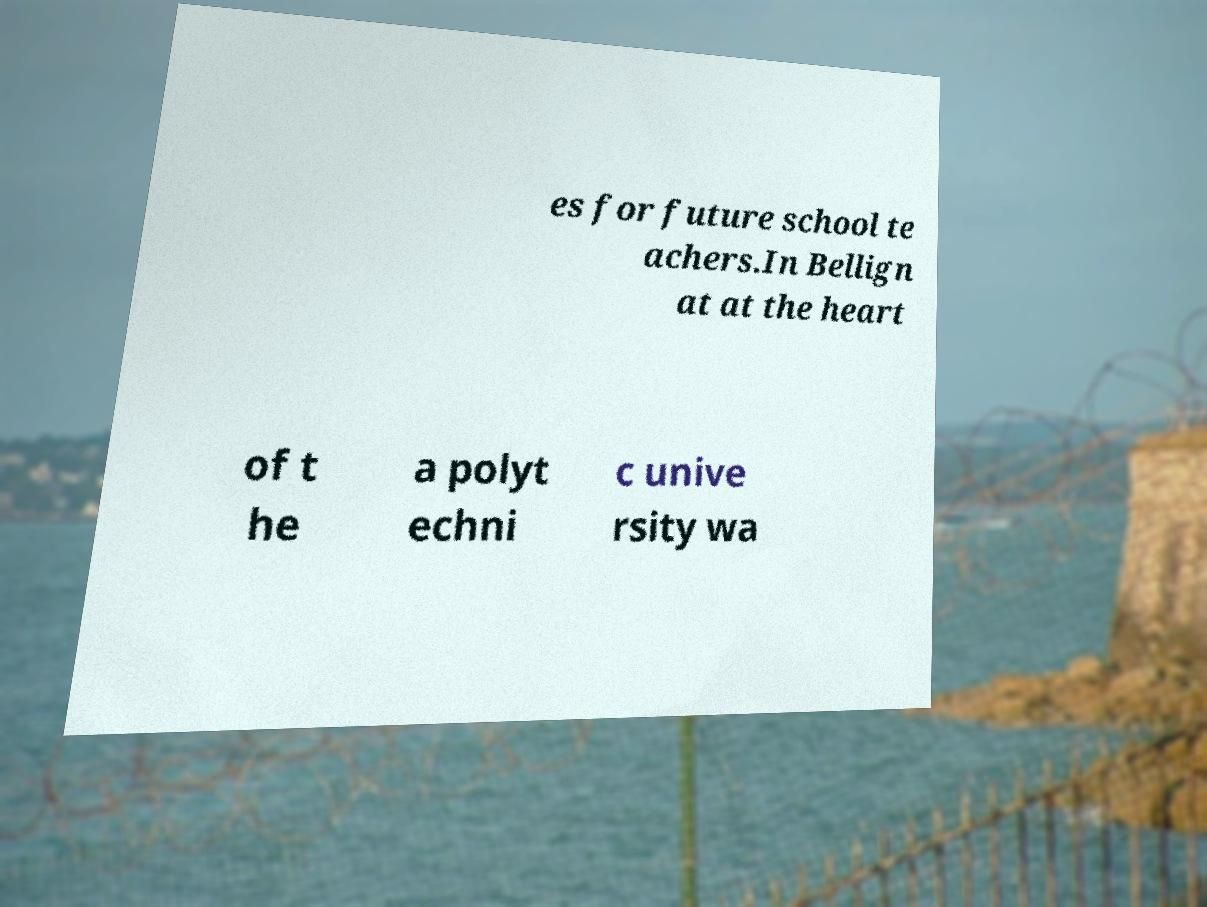Can you accurately transcribe the text from the provided image for me? es for future school te achers.In Bellign at at the heart of t he a polyt echni c unive rsity wa 